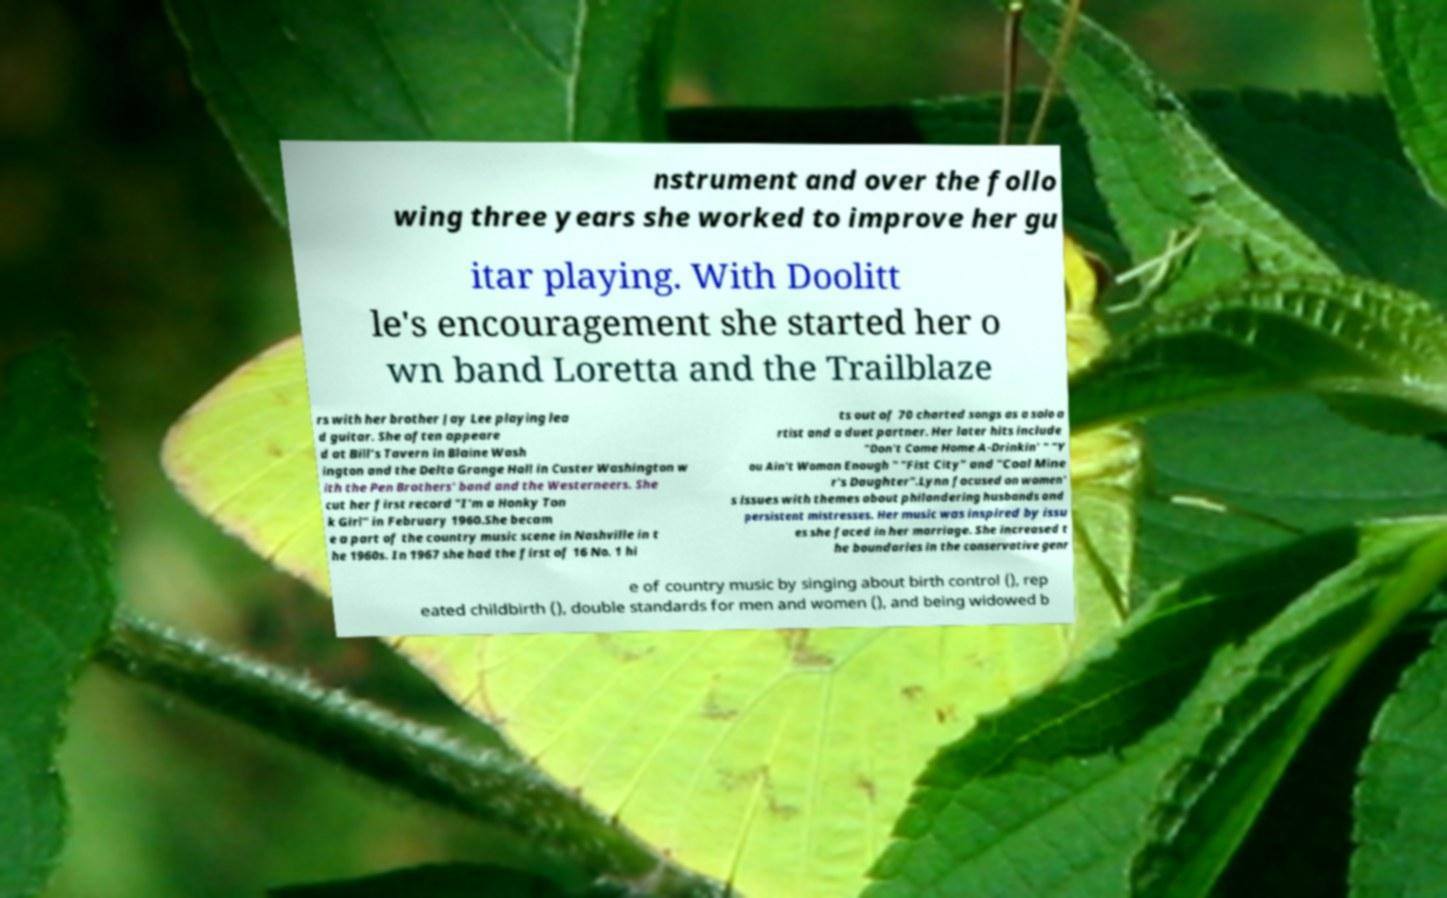Can you read and provide the text displayed in the image?This photo seems to have some interesting text. Can you extract and type it out for me? nstrument and over the follo wing three years she worked to improve her gu itar playing. With Doolitt le's encouragement she started her o wn band Loretta and the Trailblaze rs with her brother Jay Lee playing lea d guitar. She often appeare d at Bill's Tavern in Blaine Wash ington and the Delta Grange Hall in Custer Washington w ith the Pen Brothers' band and the Westerneers. She cut her first record "I'm a Honky Ton k Girl" in February 1960.She becam e a part of the country music scene in Nashville in t he 1960s. In 1967 she had the first of 16 No. 1 hi ts out of 70 charted songs as a solo a rtist and a duet partner. Her later hits include "Don't Come Home A-Drinkin' " "Y ou Ain't Woman Enough " "Fist City" and "Coal Mine r's Daughter".Lynn focused on women' s issues with themes about philandering husbands and persistent mistresses. Her music was inspired by issu es she faced in her marriage. She increased t he boundaries in the conservative genr e of country music by singing about birth control (), rep eated childbirth (), double standards for men and women (), and being widowed b 